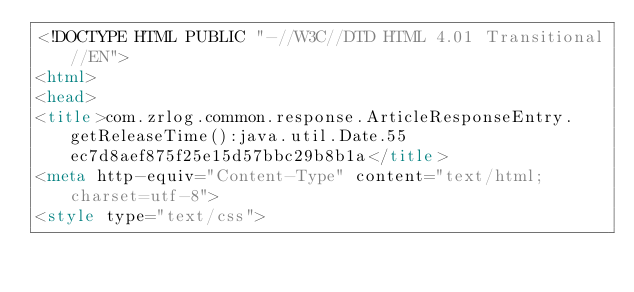Convert code to text. <code><loc_0><loc_0><loc_500><loc_500><_HTML_><!DOCTYPE HTML PUBLIC "-//W3C//DTD HTML 4.01 Transitional//EN">
<html>
<head>
<title>com.zrlog.common.response.ArticleResponseEntry.getReleaseTime():java.util.Date.55ec7d8aef875f25e15d57bbc29b8b1a</title>
<meta http-equiv="Content-Type" content="text/html; charset=utf-8">
<style type="text/css"></code> 